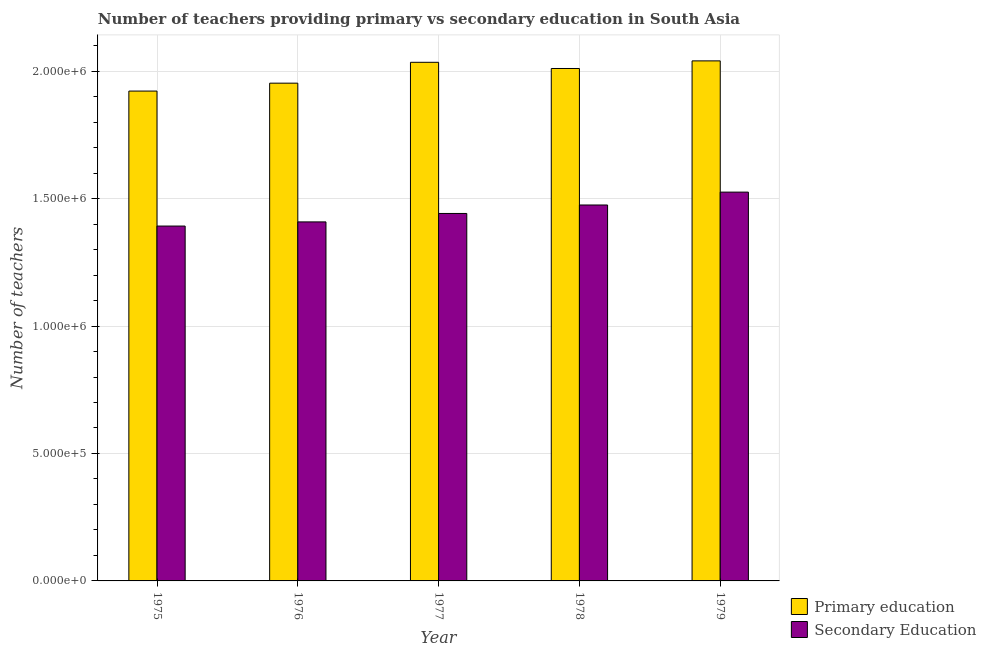How many groups of bars are there?
Your response must be concise. 5. Are the number of bars on each tick of the X-axis equal?
Ensure brevity in your answer.  Yes. What is the number of primary teachers in 1978?
Offer a very short reply. 2.01e+06. Across all years, what is the maximum number of primary teachers?
Your answer should be compact. 2.04e+06. Across all years, what is the minimum number of primary teachers?
Make the answer very short. 1.92e+06. In which year was the number of primary teachers maximum?
Keep it short and to the point. 1979. In which year was the number of primary teachers minimum?
Your answer should be very brief. 1975. What is the total number of primary teachers in the graph?
Your answer should be very brief. 9.96e+06. What is the difference between the number of primary teachers in 1976 and that in 1977?
Your answer should be compact. -8.18e+04. What is the difference between the number of secondary teachers in 1979 and the number of primary teachers in 1977?
Your answer should be compact. 8.37e+04. What is the average number of secondary teachers per year?
Your answer should be compact. 1.45e+06. What is the ratio of the number of primary teachers in 1975 to that in 1977?
Keep it short and to the point. 0.94. Is the number of secondary teachers in 1976 less than that in 1977?
Your answer should be compact. Yes. Is the difference between the number of primary teachers in 1976 and 1979 greater than the difference between the number of secondary teachers in 1976 and 1979?
Offer a very short reply. No. What is the difference between the highest and the second highest number of primary teachers?
Offer a very short reply. 5623. What is the difference between the highest and the lowest number of secondary teachers?
Give a very brief answer. 1.33e+05. In how many years, is the number of secondary teachers greater than the average number of secondary teachers taken over all years?
Keep it short and to the point. 2. Is the sum of the number of primary teachers in 1976 and 1977 greater than the maximum number of secondary teachers across all years?
Provide a succinct answer. Yes. What does the 1st bar from the left in 1976 represents?
Offer a very short reply. Primary education. What does the 1st bar from the right in 1978 represents?
Ensure brevity in your answer.  Secondary Education. Are all the bars in the graph horizontal?
Make the answer very short. No. How many years are there in the graph?
Provide a succinct answer. 5. Are the values on the major ticks of Y-axis written in scientific E-notation?
Give a very brief answer. Yes. How many legend labels are there?
Your answer should be compact. 2. What is the title of the graph?
Make the answer very short. Number of teachers providing primary vs secondary education in South Asia. What is the label or title of the X-axis?
Provide a succinct answer. Year. What is the label or title of the Y-axis?
Provide a succinct answer. Number of teachers. What is the Number of teachers in Primary education in 1975?
Offer a very short reply. 1.92e+06. What is the Number of teachers in Secondary Education in 1975?
Provide a short and direct response. 1.39e+06. What is the Number of teachers in Primary education in 1976?
Provide a succinct answer. 1.95e+06. What is the Number of teachers of Secondary Education in 1976?
Your response must be concise. 1.41e+06. What is the Number of teachers in Primary education in 1977?
Your answer should be compact. 2.03e+06. What is the Number of teachers of Secondary Education in 1977?
Give a very brief answer. 1.44e+06. What is the Number of teachers in Primary education in 1978?
Make the answer very short. 2.01e+06. What is the Number of teachers of Secondary Education in 1978?
Your answer should be compact. 1.47e+06. What is the Number of teachers in Primary education in 1979?
Make the answer very short. 2.04e+06. What is the Number of teachers in Secondary Education in 1979?
Provide a short and direct response. 1.53e+06. Across all years, what is the maximum Number of teachers in Primary education?
Provide a succinct answer. 2.04e+06. Across all years, what is the maximum Number of teachers in Secondary Education?
Offer a very short reply. 1.53e+06. Across all years, what is the minimum Number of teachers in Primary education?
Provide a short and direct response. 1.92e+06. Across all years, what is the minimum Number of teachers of Secondary Education?
Provide a short and direct response. 1.39e+06. What is the total Number of teachers of Primary education in the graph?
Give a very brief answer. 9.96e+06. What is the total Number of teachers of Secondary Education in the graph?
Offer a terse response. 7.24e+06. What is the difference between the Number of teachers of Primary education in 1975 and that in 1976?
Give a very brief answer. -3.11e+04. What is the difference between the Number of teachers of Secondary Education in 1975 and that in 1976?
Keep it short and to the point. -1.63e+04. What is the difference between the Number of teachers in Primary education in 1975 and that in 1977?
Provide a short and direct response. -1.13e+05. What is the difference between the Number of teachers in Secondary Education in 1975 and that in 1977?
Make the answer very short. -4.94e+04. What is the difference between the Number of teachers in Primary education in 1975 and that in 1978?
Give a very brief answer. -8.86e+04. What is the difference between the Number of teachers of Secondary Education in 1975 and that in 1978?
Your response must be concise. -8.26e+04. What is the difference between the Number of teachers in Primary education in 1975 and that in 1979?
Offer a very short reply. -1.18e+05. What is the difference between the Number of teachers of Secondary Education in 1975 and that in 1979?
Give a very brief answer. -1.33e+05. What is the difference between the Number of teachers in Primary education in 1976 and that in 1977?
Your answer should be very brief. -8.18e+04. What is the difference between the Number of teachers of Secondary Education in 1976 and that in 1977?
Keep it short and to the point. -3.31e+04. What is the difference between the Number of teachers of Primary education in 1976 and that in 1978?
Your answer should be compact. -5.75e+04. What is the difference between the Number of teachers in Secondary Education in 1976 and that in 1978?
Keep it short and to the point. -6.63e+04. What is the difference between the Number of teachers in Primary education in 1976 and that in 1979?
Provide a short and direct response. -8.74e+04. What is the difference between the Number of teachers in Secondary Education in 1976 and that in 1979?
Provide a short and direct response. -1.17e+05. What is the difference between the Number of teachers in Primary education in 1977 and that in 1978?
Give a very brief answer. 2.43e+04. What is the difference between the Number of teachers in Secondary Education in 1977 and that in 1978?
Make the answer very short. -3.32e+04. What is the difference between the Number of teachers in Primary education in 1977 and that in 1979?
Make the answer very short. -5623. What is the difference between the Number of teachers in Secondary Education in 1977 and that in 1979?
Provide a succinct answer. -8.37e+04. What is the difference between the Number of teachers of Primary education in 1978 and that in 1979?
Provide a short and direct response. -2.99e+04. What is the difference between the Number of teachers of Secondary Education in 1978 and that in 1979?
Give a very brief answer. -5.05e+04. What is the difference between the Number of teachers in Primary education in 1975 and the Number of teachers in Secondary Education in 1976?
Provide a succinct answer. 5.13e+05. What is the difference between the Number of teachers in Primary education in 1975 and the Number of teachers in Secondary Education in 1977?
Provide a succinct answer. 4.80e+05. What is the difference between the Number of teachers of Primary education in 1975 and the Number of teachers of Secondary Education in 1978?
Your answer should be very brief. 4.47e+05. What is the difference between the Number of teachers in Primary education in 1975 and the Number of teachers in Secondary Education in 1979?
Provide a short and direct response. 3.96e+05. What is the difference between the Number of teachers in Primary education in 1976 and the Number of teachers in Secondary Education in 1977?
Your response must be concise. 5.11e+05. What is the difference between the Number of teachers in Primary education in 1976 and the Number of teachers in Secondary Education in 1978?
Offer a terse response. 4.78e+05. What is the difference between the Number of teachers of Primary education in 1976 and the Number of teachers of Secondary Education in 1979?
Your answer should be compact. 4.28e+05. What is the difference between the Number of teachers in Primary education in 1977 and the Number of teachers in Secondary Education in 1978?
Keep it short and to the point. 5.60e+05. What is the difference between the Number of teachers in Primary education in 1977 and the Number of teachers in Secondary Education in 1979?
Make the answer very short. 5.09e+05. What is the difference between the Number of teachers of Primary education in 1978 and the Number of teachers of Secondary Education in 1979?
Provide a short and direct response. 4.85e+05. What is the average Number of teachers in Primary education per year?
Your answer should be compact. 1.99e+06. What is the average Number of teachers of Secondary Education per year?
Offer a terse response. 1.45e+06. In the year 1975, what is the difference between the Number of teachers in Primary education and Number of teachers in Secondary Education?
Offer a terse response. 5.30e+05. In the year 1976, what is the difference between the Number of teachers in Primary education and Number of teachers in Secondary Education?
Provide a short and direct response. 5.44e+05. In the year 1977, what is the difference between the Number of teachers in Primary education and Number of teachers in Secondary Education?
Offer a very short reply. 5.93e+05. In the year 1978, what is the difference between the Number of teachers in Primary education and Number of teachers in Secondary Education?
Ensure brevity in your answer.  5.36e+05. In the year 1979, what is the difference between the Number of teachers of Primary education and Number of teachers of Secondary Education?
Ensure brevity in your answer.  5.15e+05. What is the ratio of the Number of teachers of Primary education in 1975 to that in 1976?
Your answer should be compact. 0.98. What is the ratio of the Number of teachers of Secondary Education in 1975 to that in 1976?
Your answer should be very brief. 0.99. What is the ratio of the Number of teachers of Primary education in 1975 to that in 1977?
Give a very brief answer. 0.94. What is the ratio of the Number of teachers in Secondary Education in 1975 to that in 1977?
Provide a short and direct response. 0.97. What is the ratio of the Number of teachers of Primary education in 1975 to that in 1978?
Offer a very short reply. 0.96. What is the ratio of the Number of teachers of Secondary Education in 1975 to that in 1978?
Provide a short and direct response. 0.94. What is the ratio of the Number of teachers in Primary education in 1975 to that in 1979?
Provide a short and direct response. 0.94. What is the ratio of the Number of teachers of Secondary Education in 1975 to that in 1979?
Your answer should be very brief. 0.91. What is the ratio of the Number of teachers of Primary education in 1976 to that in 1977?
Ensure brevity in your answer.  0.96. What is the ratio of the Number of teachers of Secondary Education in 1976 to that in 1977?
Offer a terse response. 0.98. What is the ratio of the Number of teachers in Primary education in 1976 to that in 1978?
Your answer should be compact. 0.97. What is the ratio of the Number of teachers in Secondary Education in 1976 to that in 1978?
Your response must be concise. 0.95. What is the ratio of the Number of teachers of Primary education in 1976 to that in 1979?
Provide a succinct answer. 0.96. What is the ratio of the Number of teachers of Secondary Education in 1976 to that in 1979?
Your response must be concise. 0.92. What is the ratio of the Number of teachers in Primary education in 1977 to that in 1978?
Your response must be concise. 1.01. What is the ratio of the Number of teachers in Secondary Education in 1977 to that in 1978?
Keep it short and to the point. 0.98. What is the ratio of the Number of teachers in Primary education in 1977 to that in 1979?
Provide a short and direct response. 1. What is the ratio of the Number of teachers of Secondary Education in 1977 to that in 1979?
Offer a very short reply. 0.95. What is the ratio of the Number of teachers in Primary education in 1978 to that in 1979?
Provide a short and direct response. 0.99. What is the ratio of the Number of teachers of Secondary Education in 1978 to that in 1979?
Make the answer very short. 0.97. What is the difference between the highest and the second highest Number of teachers in Primary education?
Keep it short and to the point. 5623. What is the difference between the highest and the second highest Number of teachers in Secondary Education?
Keep it short and to the point. 5.05e+04. What is the difference between the highest and the lowest Number of teachers of Primary education?
Your answer should be compact. 1.18e+05. What is the difference between the highest and the lowest Number of teachers of Secondary Education?
Give a very brief answer. 1.33e+05. 